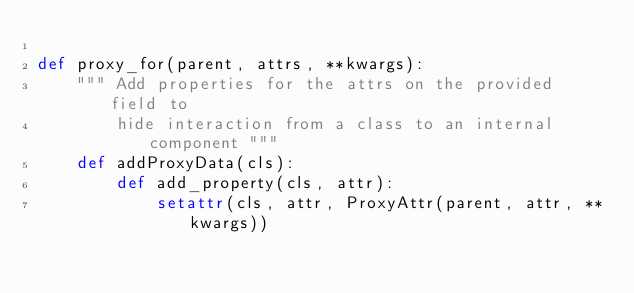Convert code to text. <code><loc_0><loc_0><loc_500><loc_500><_Python_>
def proxy_for(parent, attrs, **kwargs):
    """ Add properties for the attrs on the provided field to 
        hide interaction from a class to an internal component """
    def addProxyData(cls):
        def add_property(cls, attr):
            setattr(cls, attr, ProxyAttr(parent, attr, **kwargs))
            </code> 